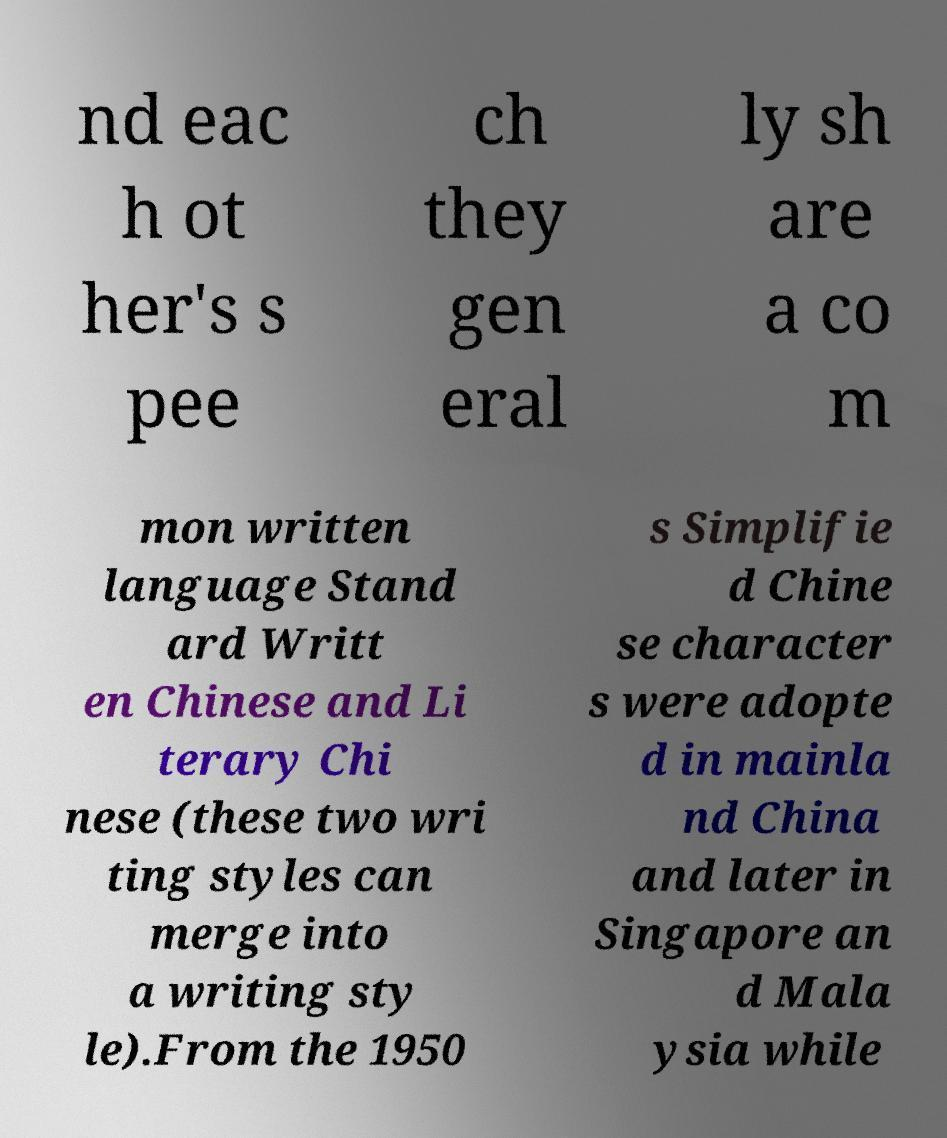For documentation purposes, I need the text within this image transcribed. Could you provide that? nd eac h ot her's s pee ch they gen eral ly sh are a co m mon written language Stand ard Writt en Chinese and Li terary Chi nese (these two wri ting styles can merge into a writing sty le).From the 1950 s Simplifie d Chine se character s were adopte d in mainla nd China and later in Singapore an d Mala ysia while 